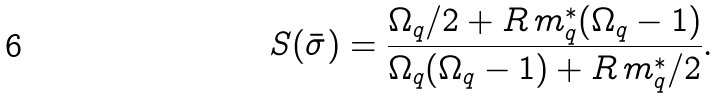<formula> <loc_0><loc_0><loc_500><loc_500>S ( \bar { \sigma } ) = \frac { \Omega _ { q } / 2 + R \, m _ { q } ^ { * } ( \Omega _ { q } - 1 ) } { \Omega _ { q } ( \Omega _ { q } - 1 ) + R \, m _ { q } ^ { * } / 2 } .</formula> 